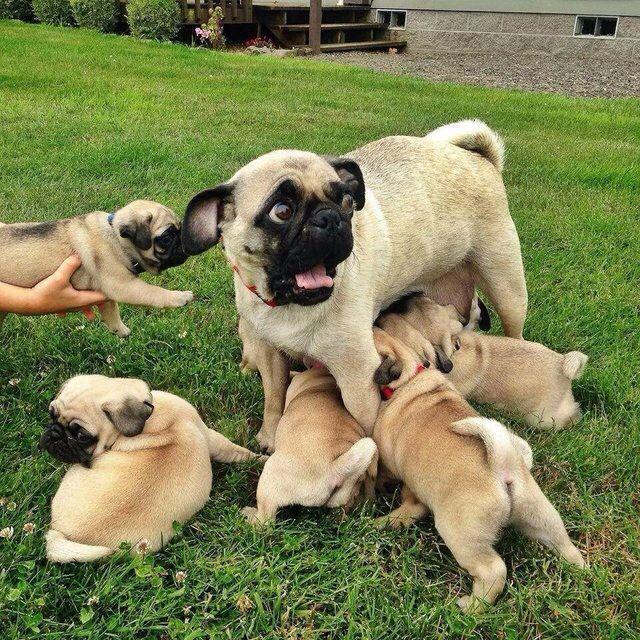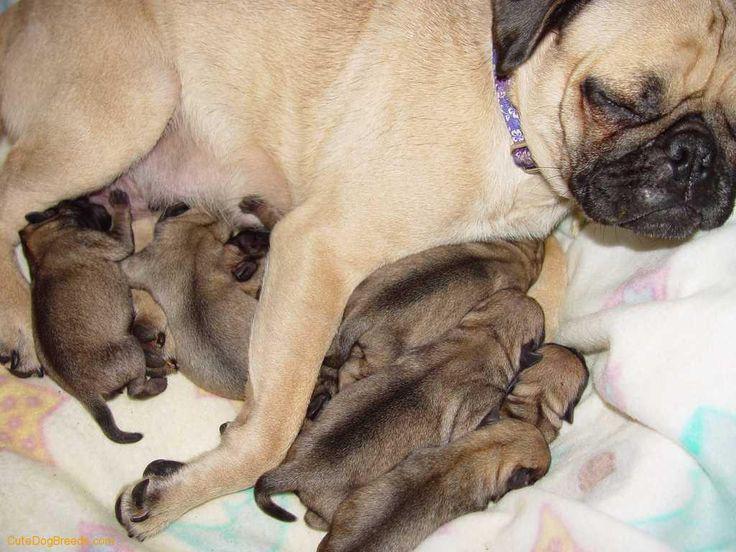The first image is the image on the left, the second image is the image on the right. Assess this claim about the two images: "There are exactly two dogs in one of the images.". Correct or not? Answer yes or no. No. The first image is the image on the left, the second image is the image on the right. Assess this claim about the two images: "There is an adult pug in each image.". Correct or not? Answer yes or no. Yes. 